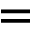<formula> <loc_0><loc_0><loc_500><loc_500>=</formula> 